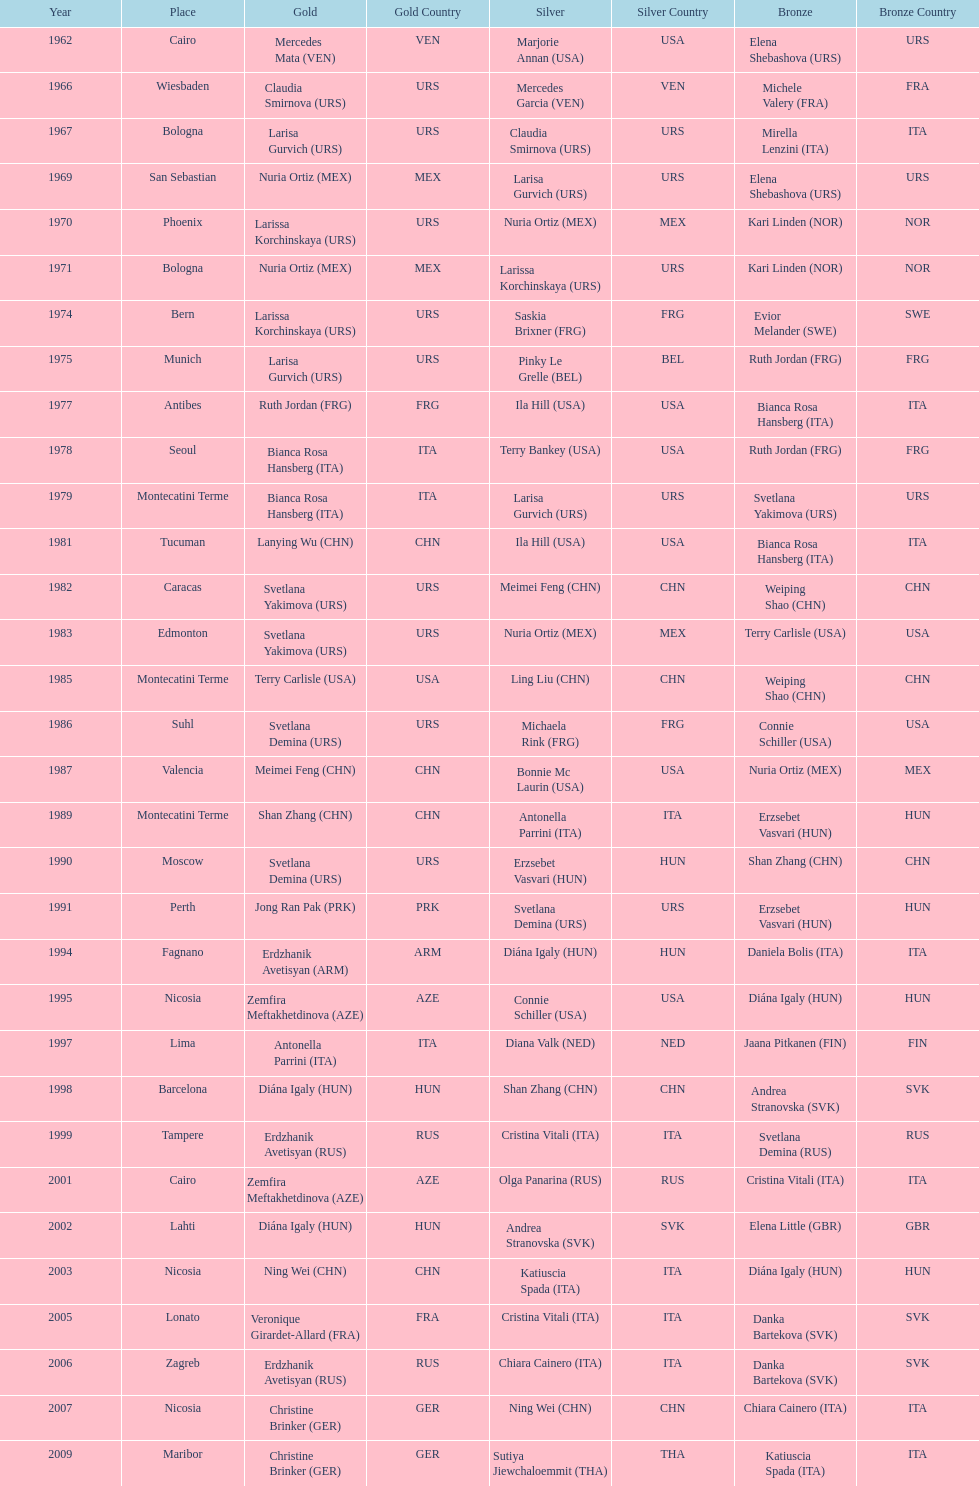Who won the only gold medal in 1962? Mercedes Mata. 